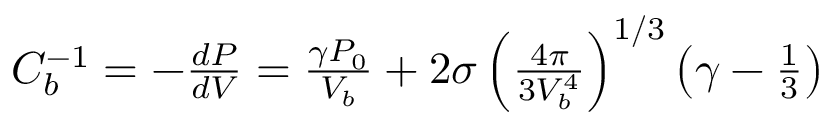<formula> <loc_0><loc_0><loc_500><loc_500>\begin{array} { r } { C _ { b } ^ { - 1 } = - \frac { d P } { d V } = \frac { \gamma P _ { 0 } } { V _ { b } } + 2 \sigma \left ( \frac { 4 \pi } { 3 V _ { b } ^ { 4 } } \right ) ^ { 1 / 3 } \left ( \gamma - \frac { 1 } { 3 } \right ) } \end{array}</formula> 